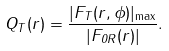<formula> <loc_0><loc_0><loc_500><loc_500>Q _ { T } ( r ) = \frac { | F _ { T } ( r , \phi ) | _ { \max } } { | F _ { 0 R } ( r ) | } .</formula> 